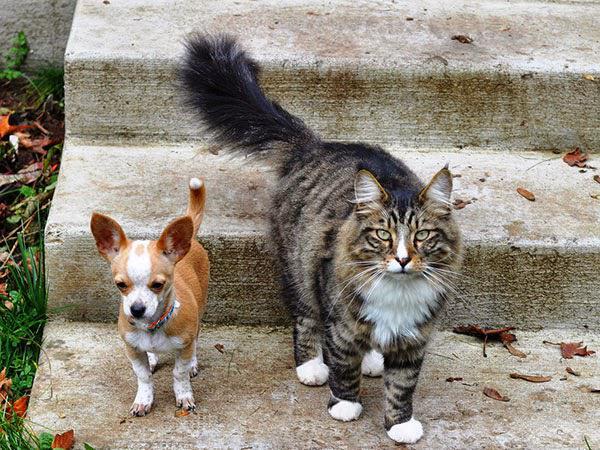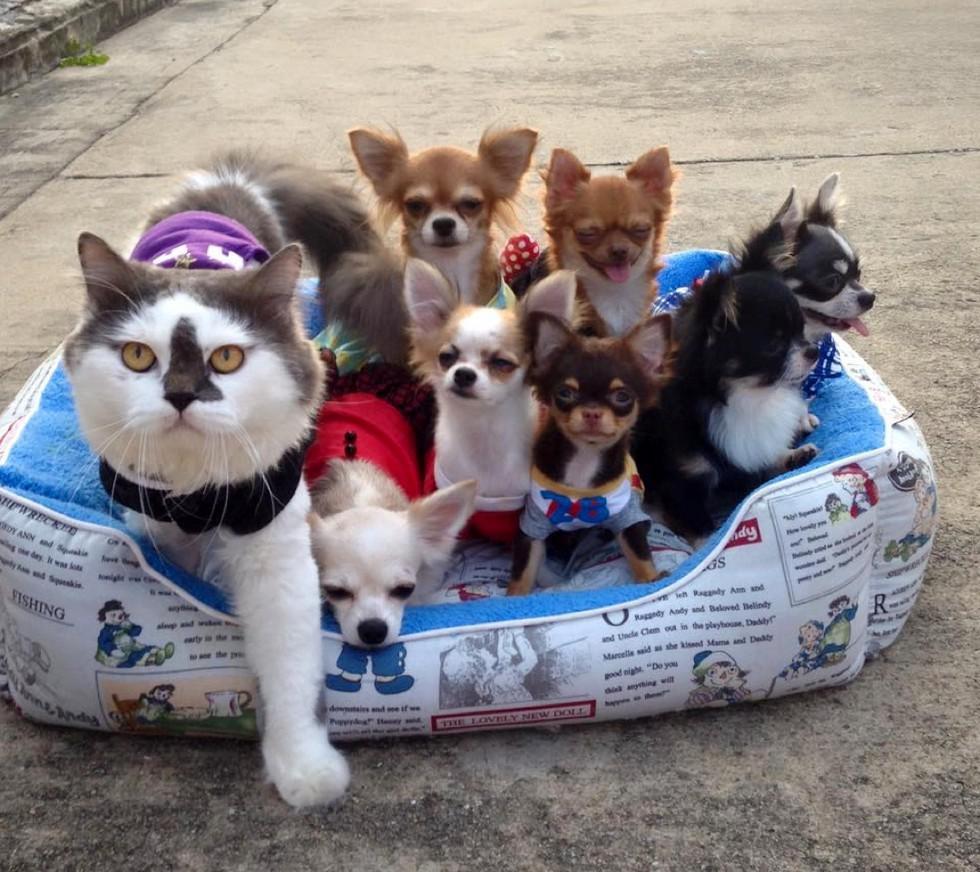The first image is the image on the left, the second image is the image on the right. For the images displayed, is the sentence "Multiple small dogs and one cat pose on a pet bed outdoors on pavement in one image." factually correct? Answer yes or no. Yes. The first image is the image on the left, the second image is the image on the right. Assess this claim about the two images: "There s exactly one cat that is not wearing any clothing.". Correct or not? Answer yes or no. Yes. 